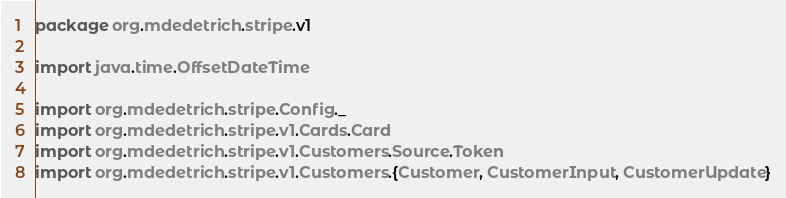Convert code to text. <code><loc_0><loc_0><loc_500><loc_500><_Scala_>package org.mdedetrich.stripe.v1

import java.time.OffsetDateTime

import org.mdedetrich.stripe.Config._
import org.mdedetrich.stripe.v1.Cards.Card
import org.mdedetrich.stripe.v1.Customers.Source.Token
import org.mdedetrich.stripe.v1.Customers.{Customer, CustomerInput, CustomerUpdate}</code> 